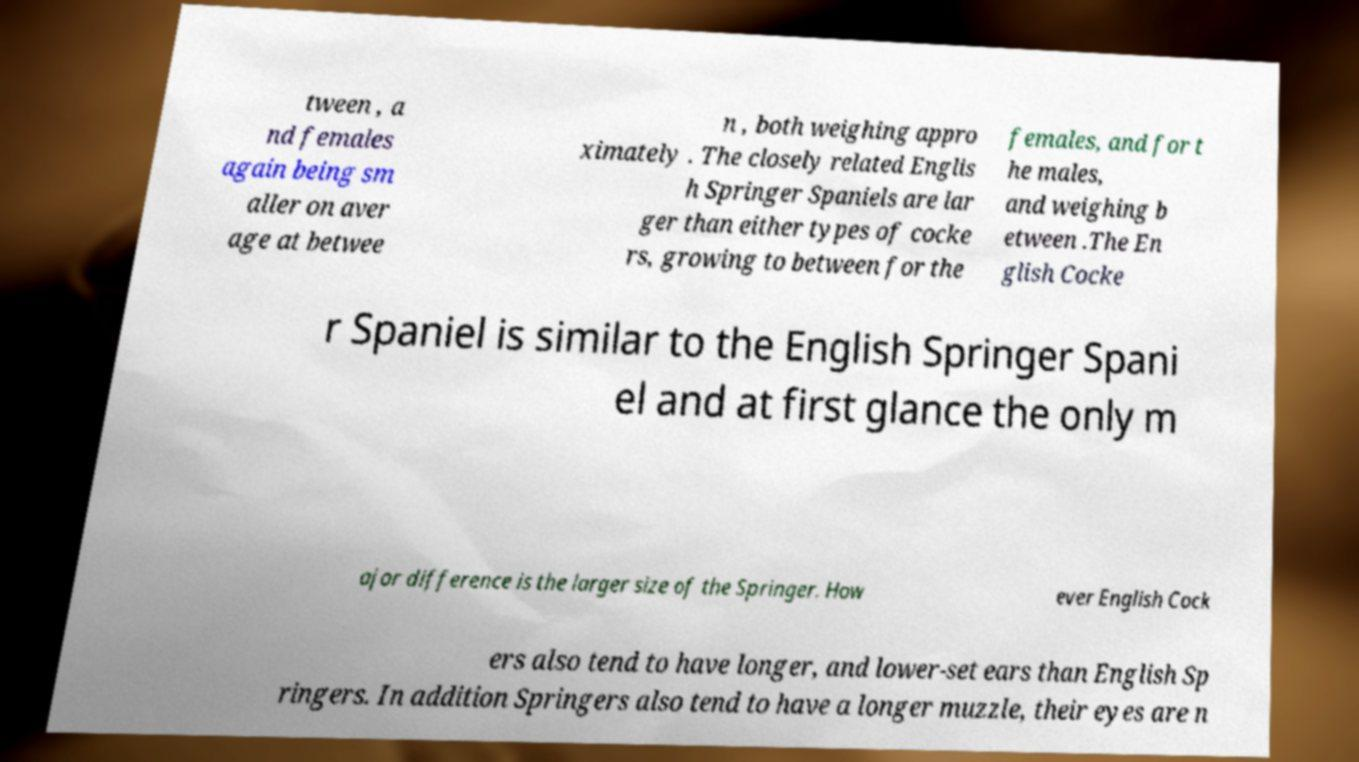What messages or text are displayed in this image? I need them in a readable, typed format. tween , a nd females again being sm aller on aver age at betwee n , both weighing appro ximately . The closely related Englis h Springer Spaniels are lar ger than either types of cocke rs, growing to between for the females, and for t he males, and weighing b etween .The En glish Cocke r Spaniel is similar to the English Springer Spani el and at first glance the only m ajor difference is the larger size of the Springer. How ever English Cock ers also tend to have longer, and lower-set ears than English Sp ringers. In addition Springers also tend to have a longer muzzle, their eyes are n 